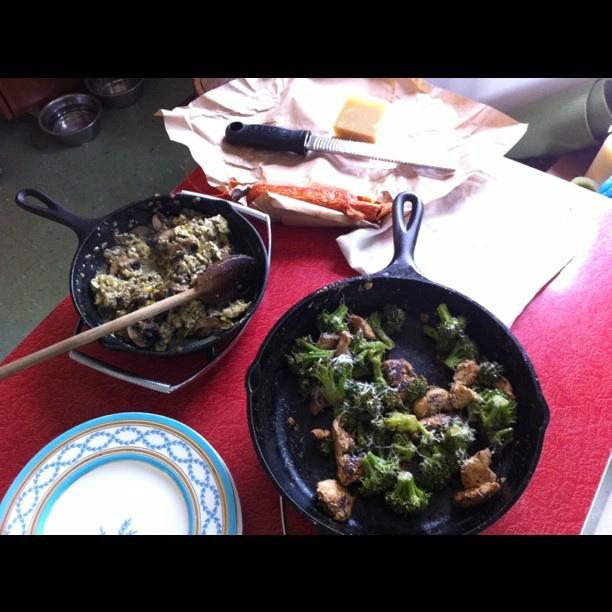What kind of skillets are being used?
Write a very short answer. Cast iron. What color are the chopsticks?
Concise answer only. Tan. Is this a high class dish?
Keep it brief. No. What activity is being shown in the pictures?
Quick response, please. Eating. What type of cuisine is being served?
Concise answer only. Chinese. 